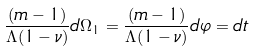<formula> <loc_0><loc_0><loc_500><loc_500>\frac { ( m - 1 ) } { \Lambda ( 1 - \nu ) } d \Omega _ { 1 } = \frac { ( m - 1 ) } { \Lambda ( 1 - \nu ) } d \varphi = d t</formula> 